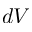<formula> <loc_0><loc_0><loc_500><loc_500>d V</formula> 